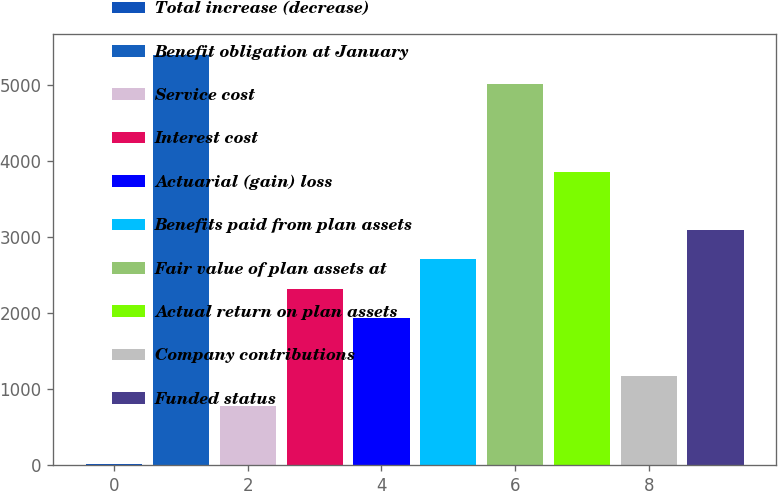Convert chart to OTSL. <chart><loc_0><loc_0><loc_500><loc_500><bar_chart><fcel>Total increase (decrease)<fcel>Benefit obligation at January<fcel>Service cost<fcel>Interest cost<fcel>Actuarial (gain) loss<fcel>Benefits paid from plan assets<fcel>Fair value of plan assets at<fcel>Actual return on plan assets<fcel>Company contributions<fcel>Funded status<nl><fcel>11<fcel>5401<fcel>781<fcel>2321<fcel>1936<fcel>2706<fcel>5016<fcel>3861<fcel>1166<fcel>3091<nl></chart> 